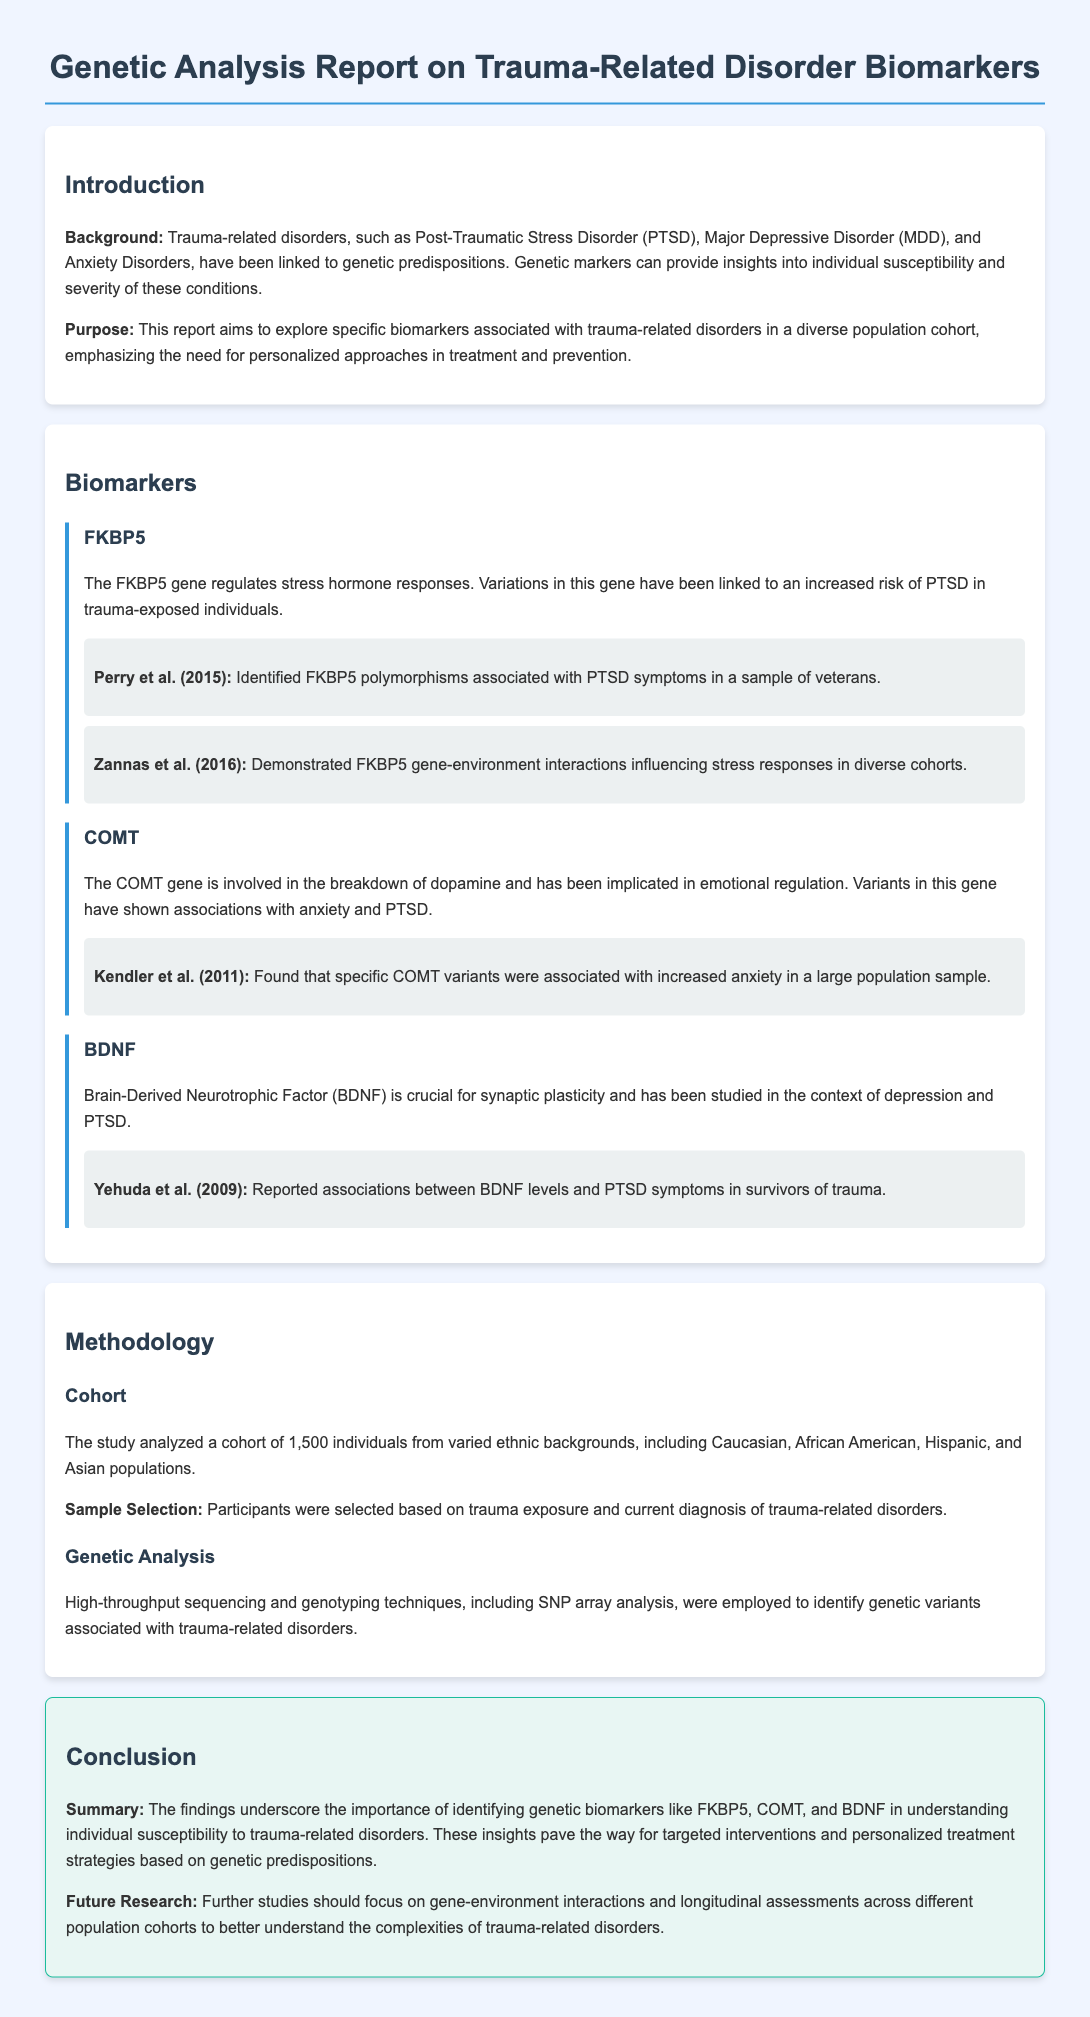What is the total number of individuals in the study cohort? The study analyzed a cohort of 1,500 individuals from varied ethnic backgrounds.
Answer: 1,500 What are the three genetic biomarkers mentioned? The report identifies FKBP5, COMT, and BDNF as genetic biomarkers.
Answer: FKBP5, COMT, BDNF Which gene is associated with the regulation of stress hormone responses? FKBP5 regulates stress hormone responses and is linked to an increased risk of PTSD.
Answer: FKBP5 Who conducted a study that reported associations between BDNF levels and PTSD symptoms? Yehuda et al. (2009) reported associations between BDNF levels and PTSD symptoms.
Answer: Yehuda et al. (2009) What is the main purpose of the report? The purpose is to explore specific biomarkers associated with trauma-related disorders in a diverse population cohort.
Answer: Explore specific biomarkers What are the ethnic backgrounds included in the cohort? The cohort includes Caucasian, African American, Hispanic, and Asian populations.
Answer: Caucasian, African American, Hispanic, Asian Which techniques were employed for genetic analysis? High-throughput sequencing and genotyping techniques, including SNP array analysis, were employed.
Answer: High-throughput sequencing and genotyping techniques What future research focus is suggested in the conclusion? Future research should focus on gene-environment interactions and longitudinal assessments.
Answer: Gene-environment interactions and longitudinal assessments 